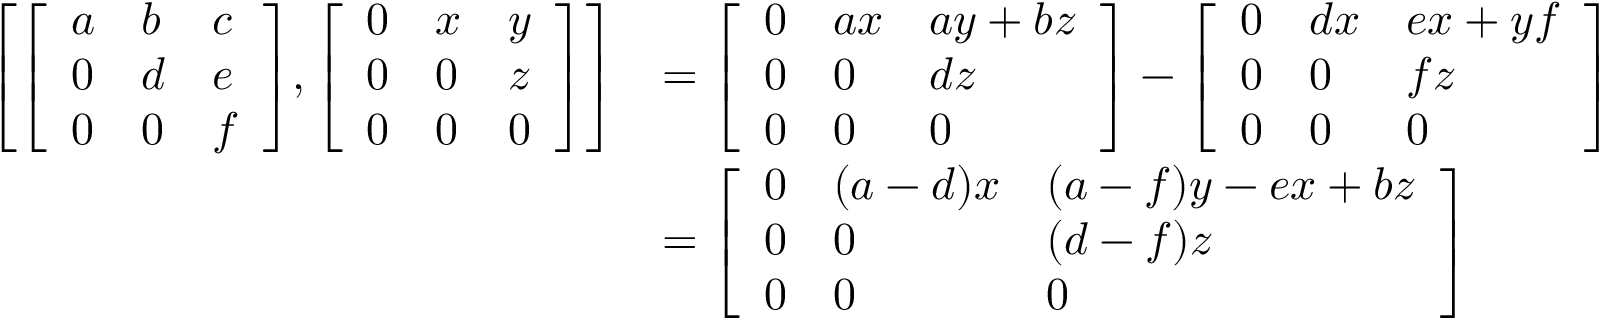<formula> <loc_0><loc_0><loc_500><loc_500>{ \begin{array} { r l } { \left [ { \left [ \begin{array} { l l l } { a } & { b } & { c } \\ { 0 } & { d } & { e } \\ { 0 } & { 0 } & { f } \end{array} \right ] } , { \left [ \begin{array} { l l l } { 0 } & { x } & { y } \\ { 0 } & { 0 } & { z } \\ { 0 } & { 0 } & { 0 } \end{array} \right ] } \right ] } & { = { \left [ \begin{array} { l l l } { 0 } & { a x } & { a y + b z } \\ { 0 } & { 0 } & { d z } \\ { 0 } & { 0 } & { 0 } \end{array} \right ] } - { \left [ \begin{array} { l l l } { 0 } & { d x } & { e x + y f } \\ { 0 } & { 0 } & { f z } \\ { 0 } & { 0 } & { 0 } \end{array} \right ] } } \\ & { = { \left [ \begin{array} { l l l } { 0 } & { ( a - d ) x } & { ( a - f ) y - e x + b z } \\ { 0 } & { 0 } & { ( d - f ) z } \\ { 0 } & { 0 } & { 0 } \end{array} \right ] } } \end{array} }</formula> 